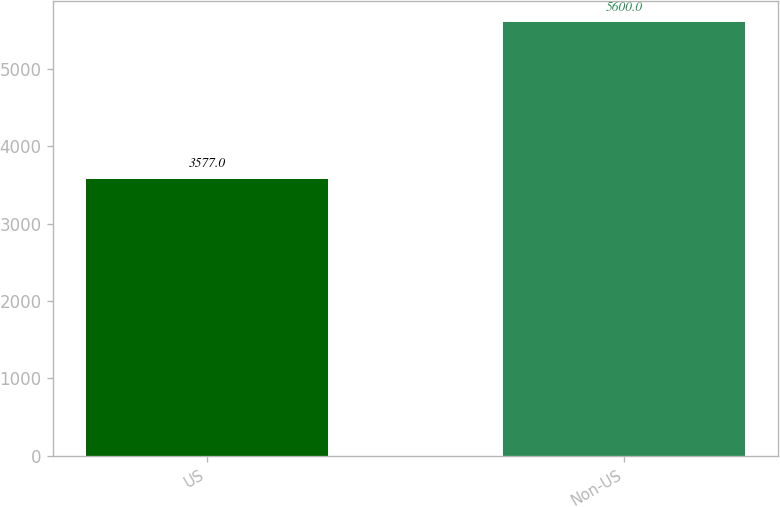Convert chart to OTSL. <chart><loc_0><loc_0><loc_500><loc_500><bar_chart><fcel>US<fcel>Non-US<nl><fcel>3577<fcel>5600<nl></chart> 